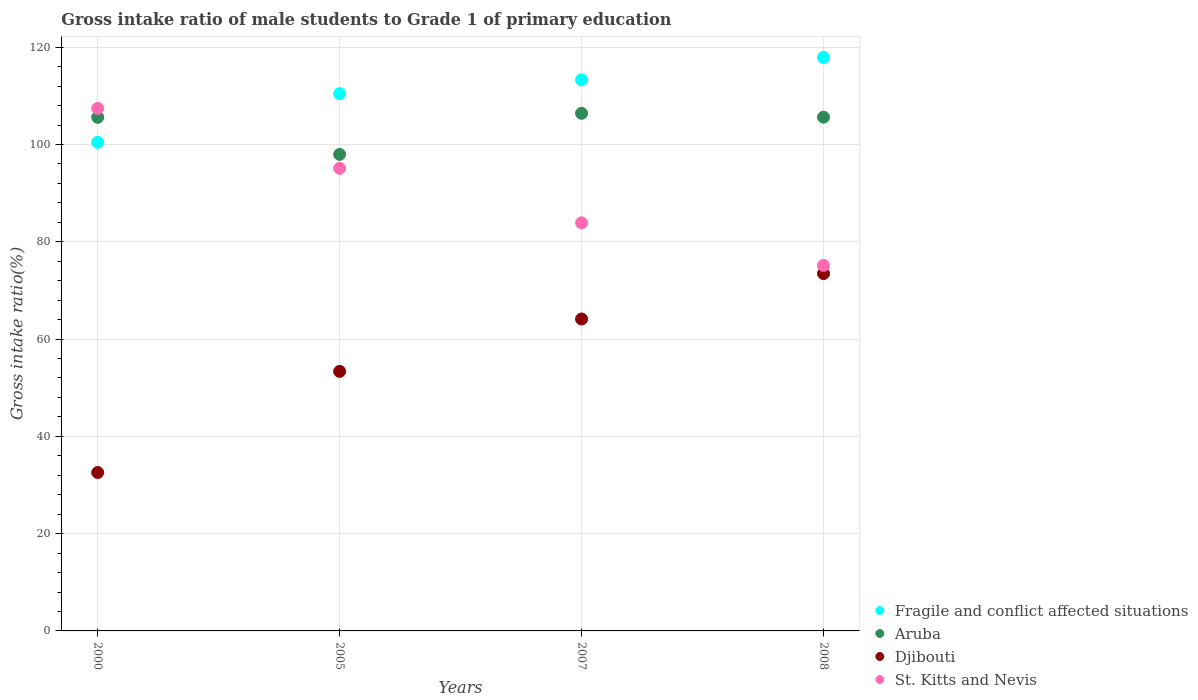How many different coloured dotlines are there?
Your response must be concise. 4. What is the gross intake ratio in Djibouti in 2008?
Your answer should be very brief. 73.47. Across all years, what is the maximum gross intake ratio in Fragile and conflict affected situations?
Make the answer very short. 117.93. Across all years, what is the minimum gross intake ratio in Djibouti?
Your response must be concise. 32.56. In which year was the gross intake ratio in Aruba maximum?
Your answer should be very brief. 2007. What is the total gross intake ratio in Aruba in the graph?
Keep it short and to the point. 415.61. What is the difference between the gross intake ratio in Aruba in 2000 and that in 2007?
Ensure brevity in your answer.  -0.82. What is the difference between the gross intake ratio in Aruba in 2005 and the gross intake ratio in Djibouti in 2008?
Your answer should be compact. 24.5. What is the average gross intake ratio in Fragile and conflict affected situations per year?
Give a very brief answer. 110.53. In the year 2005, what is the difference between the gross intake ratio in Fragile and conflict affected situations and gross intake ratio in St. Kitts and Nevis?
Provide a succinct answer. 15.36. In how many years, is the gross intake ratio in Aruba greater than 36 %?
Offer a very short reply. 4. What is the ratio of the gross intake ratio in Djibouti in 2000 to that in 2008?
Offer a very short reply. 0.44. Is the gross intake ratio in St. Kitts and Nevis in 2007 less than that in 2008?
Your answer should be very brief. No. Is the difference between the gross intake ratio in Fragile and conflict affected situations in 2000 and 2008 greater than the difference between the gross intake ratio in St. Kitts and Nevis in 2000 and 2008?
Provide a short and direct response. No. What is the difference between the highest and the second highest gross intake ratio in Aruba?
Provide a short and direct response. 0.79. What is the difference between the highest and the lowest gross intake ratio in Djibouti?
Provide a short and direct response. 40.91. In how many years, is the gross intake ratio in St. Kitts and Nevis greater than the average gross intake ratio in St. Kitts and Nevis taken over all years?
Your answer should be compact. 2. Is the sum of the gross intake ratio in Aruba in 2000 and 2007 greater than the maximum gross intake ratio in Djibouti across all years?
Your response must be concise. Yes. Is it the case that in every year, the sum of the gross intake ratio in St. Kitts and Nevis and gross intake ratio in Aruba  is greater than the sum of gross intake ratio in Djibouti and gross intake ratio in Fragile and conflict affected situations?
Give a very brief answer. No. Does the gross intake ratio in Fragile and conflict affected situations monotonically increase over the years?
Provide a succinct answer. Yes. Is the gross intake ratio in Aruba strictly greater than the gross intake ratio in Fragile and conflict affected situations over the years?
Your response must be concise. No. Is the gross intake ratio in Djibouti strictly less than the gross intake ratio in St. Kitts and Nevis over the years?
Provide a short and direct response. Yes. How many dotlines are there?
Offer a very short reply. 4. How many years are there in the graph?
Ensure brevity in your answer.  4. Are the values on the major ticks of Y-axis written in scientific E-notation?
Ensure brevity in your answer.  No. Does the graph contain any zero values?
Provide a succinct answer. No. Does the graph contain grids?
Give a very brief answer. Yes. How many legend labels are there?
Offer a terse response. 4. How are the legend labels stacked?
Provide a succinct answer. Vertical. What is the title of the graph?
Ensure brevity in your answer.  Gross intake ratio of male students to Grade 1 of primary education. Does "Vietnam" appear as one of the legend labels in the graph?
Make the answer very short. No. What is the label or title of the X-axis?
Your response must be concise. Years. What is the label or title of the Y-axis?
Your answer should be compact. Gross intake ratio(%). What is the Gross intake ratio(%) in Fragile and conflict affected situations in 2000?
Ensure brevity in your answer.  100.44. What is the Gross intake ratio(%) in Aruba in 2000?
Your answer should be compact. 105.59. What is the Gross intake ratio(%) of Djibouti in 2000?
Provide a short and direct response. 32.56. What is the Gross intake ratio(%) in St. Kitts and Nevis in 2000?
Provide a short and direct response. 107.44. What is the Gross intake ratio(%) of Fragile and conflict affected situations in 2005?
Offer a terse response. 110.47. What is the Gross intake ratio(%) in Aruba in 2005?
Keep it short and to the point. 97.97. What is the Gross intake ratio(%) of Djibouti in 2005?
Offer a terse response. 53.37. What is the Gross intake ratio(%) in St. Kitts and Nevis in 2005?
Offer a terse response. 95.11. What is the Gross intake ratio(%) of Fragile and conflict affected situations in 2007?
Give a very brief answer. 113.3. What is the Gross intake ratio(%) of Aruba in 2007?
Keep it short and to the point. 106.42. What is the Gross intake ratio(%) of Djibouti in 2007?
Offer a very short reply. 64.13. What is the Gross intake ratio(%) in St. Kitts and Nevis in 2007?
Provide a succinct answer. 83.9. What is the Gross intake ratio(%) of Fragile and conflict affected situations in 2008?
Keep it short and to the point. 117.93. What is the Gross intake ratio(%) in Aruba in 2008?
Offer a very short reply. 105.63. What is the Gross intake ratio(%) of Djibouti in 2008?
Your answer should be very brief. 73.47. What is the Gross intake ratio(%) of St. Kitts and Nevis in 2008?
Your response must be concise. 75.15. Across all years, what is the maximum Gross intake ratio(%) of Fragile and conflict affected situations?
Give a very brief answer. 117.93. Across all years, what is the maximum Gross intake ratio(%) of Aruba?
Keep it short and to the point. 106.42. Across all years, what is the maximum Gross intake ratio(%) of Djibouti?
Your response must be concise. 73.47. Across all years, what is the maximum Gross intake ratio(%) in St. Kitts and Nevis?
Give a very brief answer. 107.44. Across all years, what is the minimum Gross intake ratio(%) of Fragile and conflict affected situations?
Provide a short and direct response. 100.44. Across all years, what is the minimum Gross intake ratio(%) of Aruba?
Offer a very short reply. 97.97. Across all years, what is the minimum Gross intake ratio(%) in Djibouti?
Your answer should be very brief. 32.56. Across all years, what is the minimum Gross intake ratio(%) of St. Kitts and Nevis?
Your answer should be compact. 75.15. What is the total Gross intake ratio(%) in Fragile and conflict affected situations in the graph?
Offer a very short reply. 442.13. What is the total Gross intake ratio(%) in Aruba in the graph?
Provide a short and direct response. 415.61. What is the total Gross intake ratio(%) in Djibouti in the graph?
Make the answer very short. 223.53. What is the total Gross intake ratio(%) of St. Kitts and Nevis in the graph?
Offer a terse response. 361.61. What is the difference between the Gross intake ratio(%) of Fragile and conflict affected situations in 2000 and that in 2005?
Provide a succinct answer. -10.03. What is the difference between the Gross intake ratio(%) in Aruba in 2000 and that in 2005?
Keep it short and to the point. 7.62. What is the difference between the Gross intake ratio(%) in Djibouti in 2000 and that in 2005?
Offer a terse response. -20.81. What is the difference between the Gross intake ratio(%) of St. Kitts and Nevis in 2000 and that in 2005?
Your answer should be very brief. 12.33. What is the difference between the Gross intake ratio(%) in Fragile and conflict affected situations in 2000 and that in 2007?
Your answer should be compact. -12.86. What is the difference between the Gross intake ratio(%) of Aruba in 2000 and that in 2007?
Make the answer very short. -0.82. What is the difference between the Gross intake ratio(%) in Djibouti in 2000 and that in 2007?
Ensure brevity in your answer.  -31.57. What is the difference between the Gross intake ratio(%) in St. Kitts and Nevis in 2000 and that in 2007?
Make the answer very short. 23.53. What is the difference between the Gross intake ratio(%) in Fragile and conflict affected situations in 2000 and that in 2008?
Keep it short and to the point. -17.48. What is the difference between the Gross intake ratio(%) of Aruba in 2000 and that in 2008?
Offer a terse response. -0.03. What is the difference between the Gross intake ratio(%) in Djibouti in 2000 and that in 2008?
Give a very brief answer. -40.91. What is the difference between the Gross intake ratio(%) in St. Kitts and Nevis in 2000 and that in 2008?
Make the answer very short. 32.29. What is the difference between the Gross intake ratio(%) of Fragile and conflict affected situations in 2005 and that in 2007?
Make the answer very short. -2.83. What is the difference between the Gross intake ratio(%) of Aruba in 2005 and that in 2007?
Keep it short and to the point. -8.45. What is the difference between the Gross intake ratio(%) in Djibouti in 2005 and that in 2007?
Your answer should be very brief. -10.77. What is the difference between the Gross intake ratio(%) in St. Kitts and Nevis in 2005 and that in 2007?
Offer a terse response. 11.21. What is the difference between the Gross intake ratio(%) in Fragile and conflict affected situations in 2005 and that in 2008?
Keep it short and to the point. -7.46. What is the difference between the Gross intake ratio(%) of Aruba in 2005 and that in 2008?
Your answer should be compact. -7.66. What is the difference between the Gross intake ratio(%) of Djibouti in 2005 and that in 2008?
Keep it short and to the point. -20.1. What is the difference between the Gross intake ratio(%) of St. Kitts and Nevis in 2005 and that in 2008?
Give a very brief answer. 19.96. What is the difference between the Gross intake ratio(%) in Fragile and conflict affected situations in 2007 and that in 2008?
Give a very brief answer. -4.63. What is the difference between the Gross intake ratio(%) of Aruba in 2007 and that in 2008?
Ensure brevity in your answer.  0.79. What is the difference between the Gross intake ratio(%) of Djibouti in 2007 and that in 2008?
Provide a succinct answer. -9.33. What is the difference between the Gross intake ratio(%) of St. Kitts and Nevis in 2007 and that in 2008?
Provide a succinct answer. 8.75. What is the difference between the Gross intake ratio(%) in Fragile and conflict affected situations in 2000 and the Gross intake ratio(%) in Aruba in 2005?
Your response must be concise. 2.47. What is the difference between the Gross intake ratio(%) of Fragile and conflict affected situations in 2000 and the Gross intake ratio(%) of Djibouti in 2005?
Provide a short and direct response. 47.07. What is the difference between the Gross intake ratio(%) of Fragile and conflict affected situations in 2000 and the Gross intake ratio(%) of St. Kitts and Nevis in 2005?
Your response must be concise. 5.33. What is the difference between the Gross intake ratio(%) of Aruba in 2000 and the Gross intake ratio(%) of Djibouti in 2005?
Offer a very short reply. 52.23. What is the difference between the Gross intake ratio(%) of Aruba in 2000 and the Gross intake ratio(%) of St. Kitts and Nevis in 2005?
Offer a very short reply. 10.48. What is the difference between the Gross intake ratio(%) in Djibouti in 2000 and the Gross intake ratio(%) in St. Kitts and Nevis in 2005?
Offer a very short reply. -62.55. What is the difference between the Gross intake ratio(%) of Fragile and conflict affected situations in 2000 and the Gross intake ratio(%) of Aruba in 2007?
Keep it short and to the point. -5.97. What is the difference between the Gross intake ratio(%) of Fragile and conflict affected situations in 2000 and the Gross intake ratio(%) of Djibouti in 2007?
Ensure brevity in your answer.  36.31. What is the difference between the Gross intake ratio(%) of Fragile and conflict affected situations in 2000 and the Gross intake ratio(%) of St. Kitts and Nevis in 2007?
Provide a succinct answer. 16.54. What is the difference between the Gross intake ratio(%) of Aruba in 2000 and the Gross intake ratio(%) of Djibouti in 2007?
Keep it short and to the point. 41.46. What is the difference between the Gross intake ratio(%) of Aruba in 2000 and the Gross intake ratio(%) of St. Kitts and Nevis in 2007?
Offer a very short reply. 21.69. What is the difference between the Gross intake ratio(%) of Djibouti in 2000 and the Gross intake ratio(%) of St. Kitts and Nevis in 2007?
Make the answer very short. -51.34. What is the difference between the Gross intake ratio(%) of Fragile and conflict affected situations in 2000 and the Gross intake ratio(%) of Aruba in 2008?
Keep it short and to the point. -5.18. What is the difference between the Gross intake ratio(%) of Fragile and conflict affected situations in 2000 and the Gross intake ratio(%) of Djibouti in 2008?
Make the answer very short. 26.97. What is the difference between the Gross intake ratio(%) of Fragile and conflict affected situations in 2000 and the Gross intake ratio(%) of St. Kitts and Nevis in 2008?
Make the answer very short. 25.29. What is the difference between the Gross intake ratio(%) of Aruba in 2000 and the Gross intake ratio(%) of Djibouti in 2008?
Offer a very short reply. 32.13. What is the difference between the Gross intake ratio(%) in Aruba in 2000 and the Gross intake ratio(%) in St. Kitts and Nevis in 2008?
Provide a short and direct response. 30.44. What is the difference between the Gross intake ratio(%) in Djibouti in 2000 and the Gross intake ratio(%) in St. Kitts and Nevis in 2008?
Make the answer very short. -42.59. What is the difference between the Gross intake ratio(%) in Fragile and conflict affected situations in 2005 and the Gross intake ratio(%) in Aruba in 2007?
Your answer should be compact. 4.05. What is the difference between the Gross intake ratio(%) in Fragile and conflict affected situations in 2005 and the Gross intake ratio(%) in Djibouti in 2007?
Make the answer very short. 46.34. What is the difference between the Gross intake ratio(%) of Fragile and conflict affected situations in 2005 and the Gross intake ratio(%) of St. Kitts and Nevis in 2007?
Offer a terse response. 26.56. What is the difference between the Gross intake ratio(%) in Aruba in 2005 and the Gross intake ratio(%) in Djibouti in 2007?
Provide a succinct answer. 33.84. What is the difference between the Gross intake ratio(%) of Aruba in 2005 and the Gross intake ratio(%) of St. Kitts and Nevis in 2007?
Provide a short and direct response. 14.07. What is the difference between the Gross intake ratio(%) of Djibouti in 2005 and the Gross intake ratio(%) of St. Kitts and Nevis in 2007?
Provide a succinct answer. -30.54. What is the difference between the Gross intake ratio(%) in Fragile and conflict affected situations in 2005 and the Gross intake ratio(%) in Aruba in 2008?
Your answer should be compact. 4.84. What is the difference between the Gross intake ratio(%) of Fragile and conflict affected situations in 2005 and the Gross intake ratio(%) of Djibouti in 2008?
Your answer should be very brief. 37. What is the difference between the Gross intake ratio(%) in Fragile and conflict affected situations in 2005 and the Gross intake ratio(%) in St. Kitts and Nevis in 2008?
Keep it short and to the point. 35.32. What is the difference between the Gross intake ratio(%) of Aruba in 2005 and the Gross intake ratio(%) of Djibouti in 2008?
Ensure brevity in your answer.  24.5. What is the difference between the Gross intake ratio(%) of Aruba in 2005 and the Gross intake ratio(%) of St. Kitts and Nevis in 2008?
Ensure brevity in your answer.  22.82. What is the difference between the Gross intake ratio(%) in Djibouti in 2005 and the Gross intake ratio(%) in St. Kitts and Nevis in 2008?
Offer a very short reply. -21.79. What is the difference between the Gross intake ratio(%) of Fragile and conflict affected situations in 2007 and the Gross intake ratio(%) of Aruba in 2008?
Give a very brief answer. 7.67. What is the difference between the Gross intake ratio(%) in Fragile and conflict affected situations in 2007 and the Gross intake ratio(%) in Djibouti in 2008?
Your answer should be compact. 39.83. What is the difference between the Gross intake ratio(%) of Fragile and conflict affected situations in 2007 and the Gross intake ratio(%) of St. Kitts and Nevis in 2008?
Your response must be concise. 38.14. What is the difference between the Gross intake ratio(%) in Aruba in 2007 and the Gross intake ratio(%) in Djibouti in 2008?
Provide a succinct answer. 32.95. What is the difference between the Gross intake ratio(%) in Aruba in 2007 and the Gross intake ratio(%) in St. Kitts and Nevis in 2008?
Offer a terse response. 31.26. What is the difference between the Gross intake ratio(%) of Djibouti in 2007 and the Gross intake ratio(%) of St. Kitts and Nevis in 2008?
Offer a very short reply. -11.02. What is the average Gross intake ratio(%) of Fragile and conflict affected situations per year?
Make the answer very short. 110.53. What is the average Gross intake ratio(%) of Aruba per year?
Keep it short and to the point. 103.9. What is the average Gross intake ratio(%) in Djibouti per year?
Give a very brief answer. 55.88. What is the average Gross intake ratio(%) in St. Kitts and Nevis per year?
Give a very brief answer. 90.4. In the year 2000, what is the difference between the Gross intake ratio(%) of Fragile and conflict affected situations and Gross intake ratio(%) of Aruba?
Keep it short and to the point. -5.15. In the year 2000, what is the difference between the Gross intake ratio(%) in Fragile and conflict affected situations and Gross intake ratio(%) in Djibouti?
Keep it short and to the point. 67.88. In the year 2000, what is the difference between the Gross intake ratio(%) in Fragile and conflict affected situations and Gross intake ratio(%) in St. Kitts and Nevis?
Ensure brevity in your answer.  -7. In the year 2000, what is the difference between the Gross intake ratio(%) of Aruba and Gross intake ratio(%) of Djibouti?
Your response must be concise. 73.03. In the year 2000, what is the difference between the Gross intake ratio(%) of Aruba and Gross intake ratio(%) of St. Kitts and Nevis?
Your answer should be compact. -1.84. In the year 2000, what is the difference between the Gross intake ratio(%) in Djibouti and Gross intake ratio(%) in St. Kitts and Nevis?
Keep it short and to the point. -74.88. In the year 2005, what is the difference between the Gross intake ratio(%) of Fragile and conflict affected situations and Gross intake ratio(%) of Aruba?
Your answer should be compact. 12.5. In the year 2005, what is the difference between the Gross intake ratio(%) of Fragile and conflict affected situations and Gross intake ratio(%) of Djibouti?
Give a very brief answer. 57.1. In the year 2005, what is the difference between the Gross intake ratio(%) of Fragile and conflict affected situations and Gross intake ratio(%) of St. Kitts and Nevis?
Make the answer very short. 15.36. In the year 2005, what is the difference between the Gross intake ratio(%) in Aruba and Gross intake ratio(%) in Djibouti?
Offer a very short reply. 44.6. In the year 2005, what is the difference between the Gross intake ratio(%) in Aruba and Gross intake ratio(%) in St. Kitts and Nevis?
Offer a very short reply. 2.86. In the year 2005, what is the difference between the Gross intake ratio(%) of Djibouti and Gross intake ratio(%) of St. Kitts and Nevis?
Give a very brief answer. -41.74. In the year 2007, what is the difference between the Gross intake ratio(%) in Fragile and conflict affected situations and Gross intake ratio(%) in Aruba?
Your response must be concise. 6.88. In the year 2007, what is the difference between the Gross intake ratio(%) of Fragile and conflict affected situations and Gross intake ratio(%) of Djibouti?
Give a very brief answer. 49.16. In the year 2007, what is the difference between the Gross intake ratio(%) in Fragile and conflict affected situations and Gross intake ratio(%) in St. Kitts and Nevis?
Keep it short and to the point. 29.39. In the year 2007, what is the difference between the Gross intake ratio(%) in Aruba and Gross intake ratio(%) in Djibouti?
Give a very brief answer. 42.28. In the year 2007, what is the difference between the Gross intake ratio(%) in Aruba and Gross intake ratio(%) in St. Kitts and Nevis?
Give a very brief answer. 22.51. In the year 2007, what is the difference between the Gross intake ratio(%) of Djibouti and Gross intake ratio(%) of St. Kitts and Nevis?
Give a very brief answer. -19.77. In the year 2008, what is the difference between the Gross intake ratio(%) of Fragile and conflict affected situations and Gross intake ratio(%) of Aruba?
Keep it short and to the point. 12.3. In the year 2008, what is the difference between the Gross intake ratio(%) of Fragile and conflict affected situations and Gross intake ratio(%) of Djibouti?
Your answer should be compact. 44.46. In the year 2008, what is the difference between the Gross intake ratio(%) of Fragile and conflict affected situations and Gross intake ratio(%) of St. Kitts and Nevis?
Give a very brief answer. 42.77. In the year 2008, what is the difference between the Gross intake ratio(%) of Aruba and Gross intake ratio(%) of Djibouti?
Ensure brevity in your answer.  32.16. In the year 2008, what is the difference between the Gross intake ratio(%) of Aruba and Gross intake ratio(%) of St. Kitts and Nevis?
Your response must be concise. 30.47. In the year 2008, what is the difference between the Gross intake ratio(%) of Djibouti and Gross intake ratio(%) of St. Kitts and Nevis?
Your answer should be compact. -1.69. What is the ratio of the Gross intake ratio(%) of Fragile and conflict affected situations in 2000 to that in 2005?
Your response must be concise. 0.91. What is the ratio of the Gross intake ratio(%) of Aruba in 2000 to that in 2005?
Make the answer very short. 1.08. What is the ratio of the Gross intake ratio(%) in Djibouti in 2000 to that in 2005?
Offer a very short reply. 0.61. What is the ratio of the Gross intake ratio(%) of St. Kitts and Nevis in 2000 to that in 2005?
Your response must be concise. 1.13. What is the ratio of the Gross intake ratio(%) of Fragile and conflict affected situations in 2000 to that in 2007?
Your answer should be very brief. 0.89. What is the ratio of the Gross intake ratio(%) in Aruba in 2000 to that in 2007?
Offer a terse response. 0.99. What is the ratio of the Gross intake ratio(%) of Djibouti in 2000 to that in 2007?
Provide a succinct answer. 0.51. What is the ratio of the Gross intake ratio(%) in St. Kitts and Nevis in 2000 to that in 2007?
Your response must be concise. 1.28. What is the ratio of the Gross intake ratio(%) of Fragile and conflict affected situations in 2000 to that in 2008?
Your answer should be very brief. 0.85. What is the ratio of the Gross intake ratio(%) in Djibouti in 2000 to that in 2008?
Your answer should be compact. 0.44. What is the ratio of the Gross intake ratio(%) of St. Kitts and Nevis in 2000 to that in 2008?
Keep it short and to the point. 1.43. What is the ratio of the Gross intake ratio(%) of Aruba in 2005 to that in 2007?
Your answer should be compact. 0.92. What is the ratio of the Gross intake ratio(%) in Djibouti in 2005 to that in 2007?
Your response must be concise. 0.83. What is the ratio of the Gross intake ratio(%) of St. Kitts and Nevis in 2005 to that in 2007?
Provide a short and direct response. 1.13. What is the ratio of the Gross intake ratio(%) of Fragile and conflict affected situations in 2005 to that in 2008?
Keep it short and to the point. 0.94. What is the ratio of the Gross intake ratio(%) in Aruba in 2005 to that in 2008?
Offer a very short reply. 0.93. What is the ratio of the Gross intake ratio(%) of Djibouti in 2005 to that in 2008?
Ensure brevity in your answer.  0.73. What is the ratio of the Gross intake ratio(%) of St. Kitts and Nevis in 2005 to that in 2008?
Ensure brevity in your answer.  1.27. What is the ratio of the Gross intake ratio(%) of Fragile and conflict affected situations in 2007 to that in 2008?
Offer a very short reply. 0.96. What is the ratio of the Gross intake ratio(%) of Aruba in 2007 to that in 2008?
Offer a terse response. 1.01. What is the ratio of the Gross intake ratio(%) of Djibouti in 2007 to that in 2008?
Give a very brief answer. 0.87. What is the ratio of the Gross intake ratio(%) of St. Kitts and Nevis in 2007 to that in 2008?
Offer a very short reply. 1.12. What is the difference between the highest and the second highest Gross intake ratio(%) in Fragile and conflict affected situations?
Your answer should be very brief. 4.63. What is the difference between the highest and the second highest Gross intake ratio(%) in Aruba?
Your response must be concise. 0.79. What is the difference between the highest and the second highest Gross intake ratio(%) in Djibouti?
Offer a very short reply. 9.33. What is the difference between the highest and the second highest Gross intake ratio(%) of St. Kitts and Nevis?
Your response must be concise. 12.33. What is the difference between the highest and the lowest Gross intake ratio(%) in Fragile and conflict affected situations?
Ensure brevity in your answer.  17.48. What is the difference between the highest and the lowest Gross intake ratio(%) of Aruba?
Offer a terse response. 8.45. What is the difference between the highest and the lowest Gross intake ratio(%) of Djibouti?
Provide a short and direct response. 40.91. What is the difference between the highest and the lowest Gross intake ratio(%) in St. Kitts and Nevis?
Offer a terse response. 32.29. 